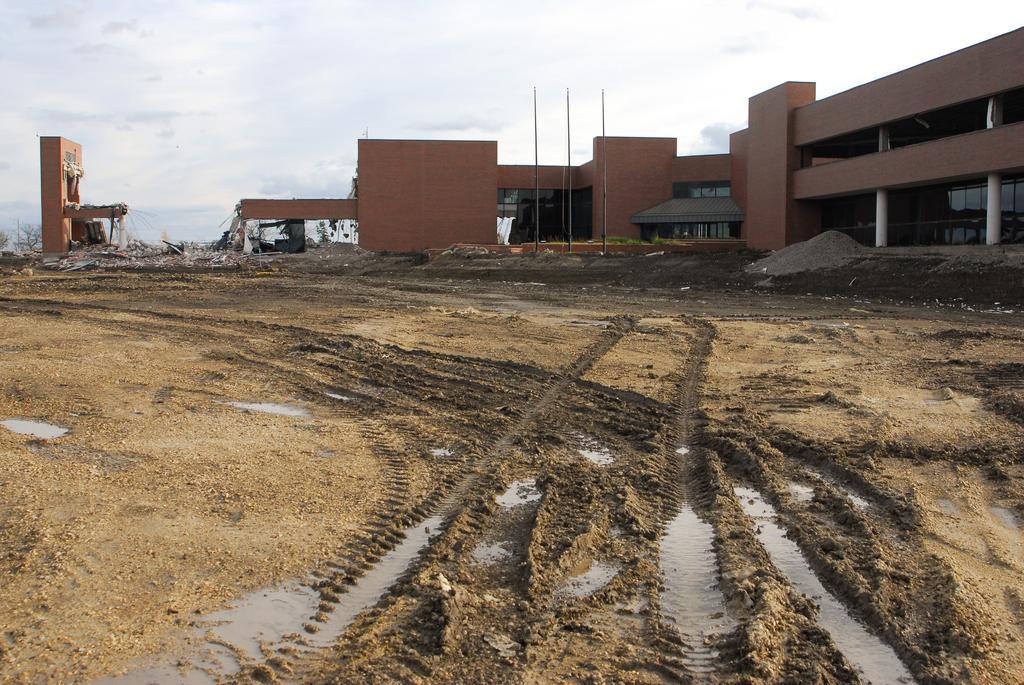Describe this image in one or two sentences. In this picture, we can see buildings with windows, pillars, and we can see the ground with some water on the ground, and some objects, poles and the sky. 